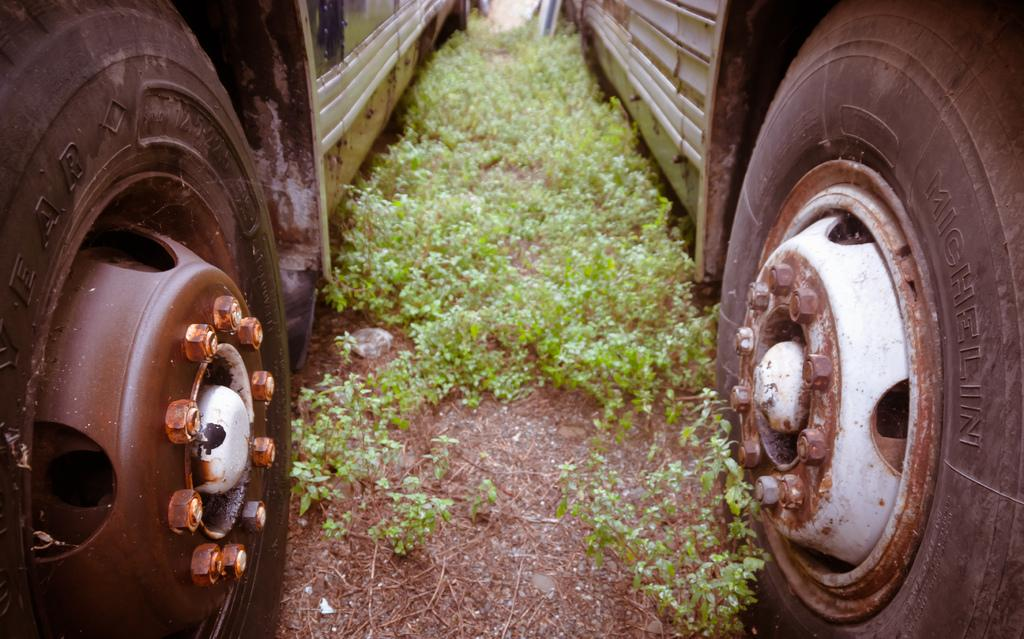How many vehicles can be seen in the image? A: There are two vehicles in the image. Where are the vehicles located? The vehicles are on land. What type of vegetation is present in the image? There are small plants in the image. What type of answer can be seen written on the vehicles in the image? There are no answers written on the vehicles in the image. Can you tell me how many times the word "print" appears in the image? The word "print" does not appear in the image. Is there a comb visible in the image? There is no comb present in the image. 